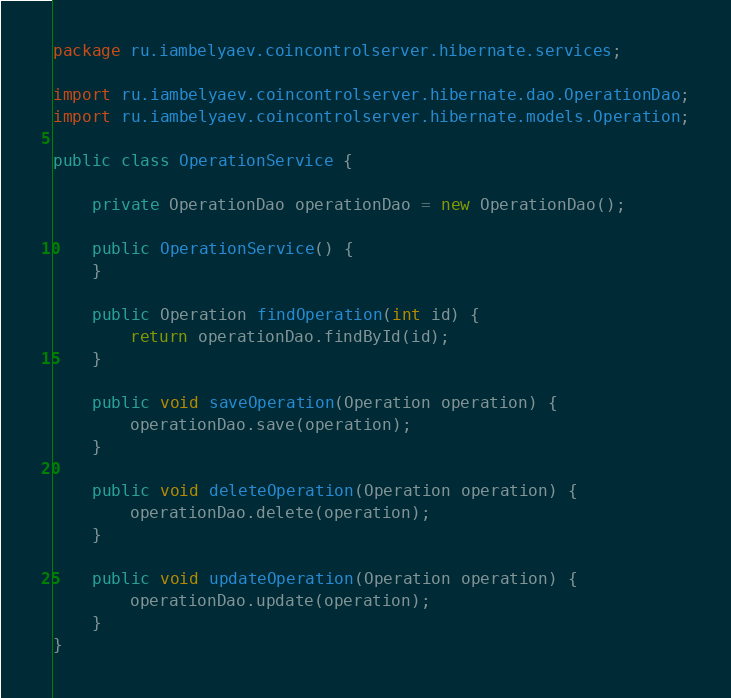Convert code to text. <code><loc_0><loc_0><loc_500><loc_500><_Java_>package ru.iambelyaev.coincontrolserver.hibernate.services;

import ru.iambelyaev.coincontrolserver.hibernate.dao.OperationDao;
import ru.iambelyaev.coincontrolserver.hibernate.models.Operation;

public class OperationService {

    private OperationDao operationDao = new OperationDao();

    public OperationService() {
    }

    public Operation findOperation(int id) {
        return operationDao.findById(id);
    }

    public void saveOperation(Operation operation) {
        operationDao.save(operation);
    }

    public void deleteOperation(Operation operation) {
        operationDao.delete(operation);
    }

    public void updateOperation(Operation operation) {
        operationDao.update(operation);
    }
}
</code> 